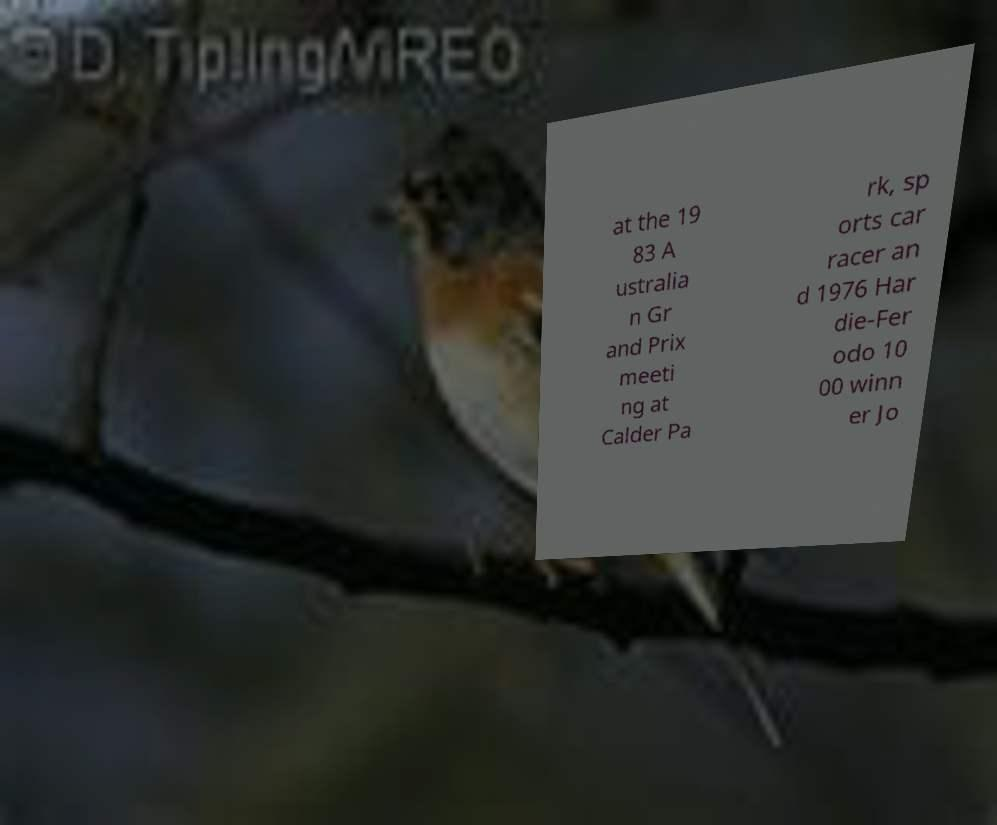Please identify and transcribe the text found in this image. at the 19 83 A ustralia n Gr and Prix meeti ng at Calder Pa rk, sp orts car racer an d 1976 Har die-Fer odo 10 00 winn er Jo 